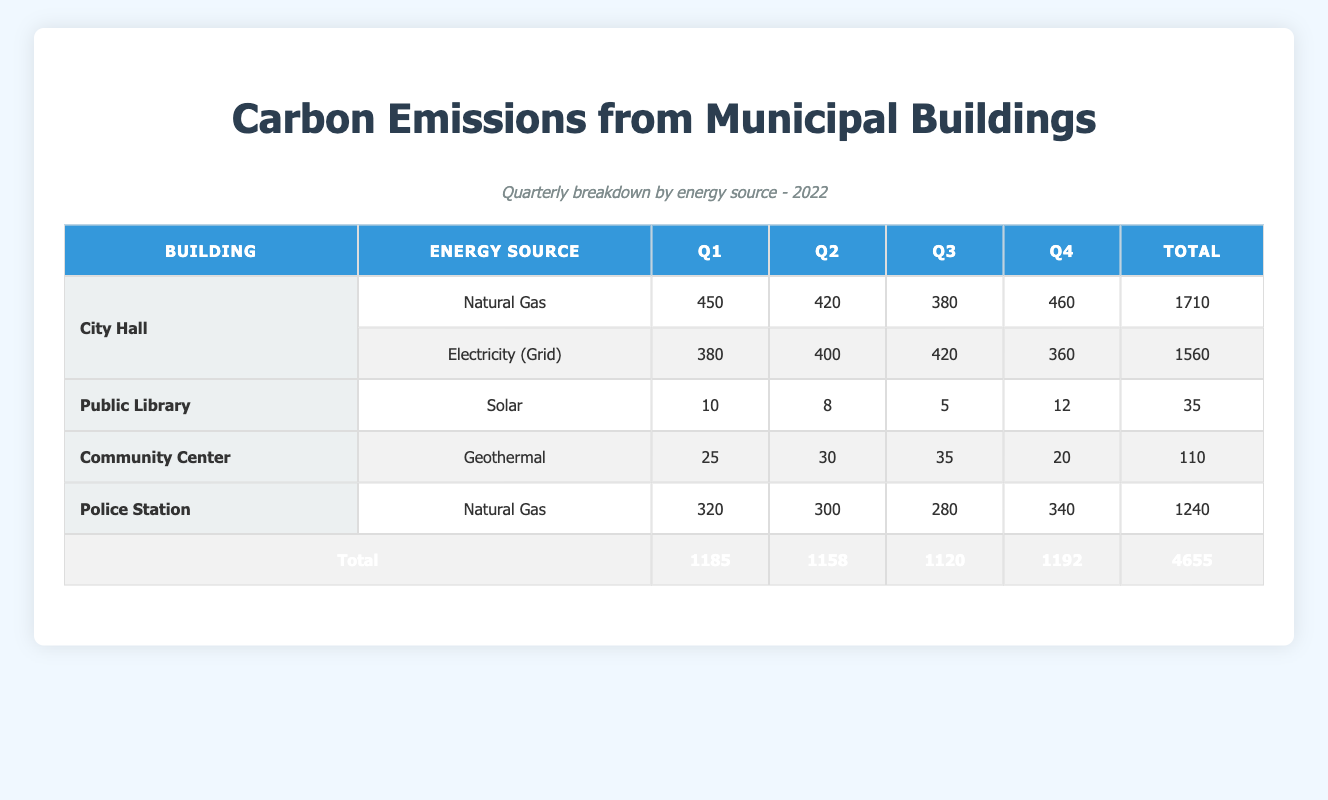What is the total carbon emissions from City Hall for the year 2022? To find the total emissions, we need to add the emissions from both energy sources used by City Hall across all four quarters: Natural Gas (1710 tons) and Electricity (1560 tons). Therefore, the total is 1710 + 1560 = 3270 tons.
Answer: 3270 tons Which building had the lowest total carbon emissions in 2022? Looking at the total emissions for each building: City Hall (3270 tons), Public Library (35 tons), Community Center (110 tons), and Police Station (1240 tons). Public Library has the lowest at 35 tons.
Answer: Public Library What was the change in carbon emissions from Natural Gas in the Police Station from Q1 to Q4? For the Police Station, Natural Gas emissions in Q1 were 320 tons and in Q4 they were 340 tons. The change is calculated by subtracting Q1 from Q4: 340 - 320 = 20 tons increase.
Answer: 20 tons increase Did the Community Center have higher emissions in Q3 compared to Q1? For the Community Center, the emissions in Q3 were 35 tons and in Q1 they were 25 tons. Since 35 is greater than 25, the statement is true.
Answer: Yes What is the average carbon emissions from Electricity (Grid) at City Hall throughout the year? The emissions for Electricity (Grid) across the quarters are 380, 400, 420, and 360 tons. To find the average, we sum these values (380 + 400 + 420 + 360 = 1560 tons) and divide by the number of quarters (4). So the average is 1560 / 4 = 390 tons.
Answer: 390 tons Which energy source produced the highest total carbon emissions across all buildings? We will sum the emissions for each energy source: Natural Gas (1710 + 1240 = 2950 tons), Electricity (1560 tons), Solar (35 tons), and Geothermal (110 tons). Natural Gas has the highest at 2950 tons compared to the others.
Answer: Natural Gas What was the total carbon emissions for the Police Station in Q2 and Q3 combined? The emissions in Q2 for the Police Station were 300 tons and in Q3 they were 280 tons. We sum these values: 300 + 280 = 580 tons total for Q2 and Q3.
Answer: 580 tons Is it true that the carbon emissions from Solar energy decreased from Q1 to Q3 for the Public Library? The Public Library had 10 tons in Q1 and 5 tons in Q3 with Solar energy, meaning emissions did decrease from Q1 to Q3, confirming the statement is true.
Answer: Yes What is the total carbon emissions for all buildings in Q4? The emissions for Q4 are: City Hall (460 + 360), Public Library (12), Community Center (20), and Police Station (340). Therefore, the sum is 460 + 360 + 12 + 20 + 340 = 1192 tons.
Answer: 1192 tons 